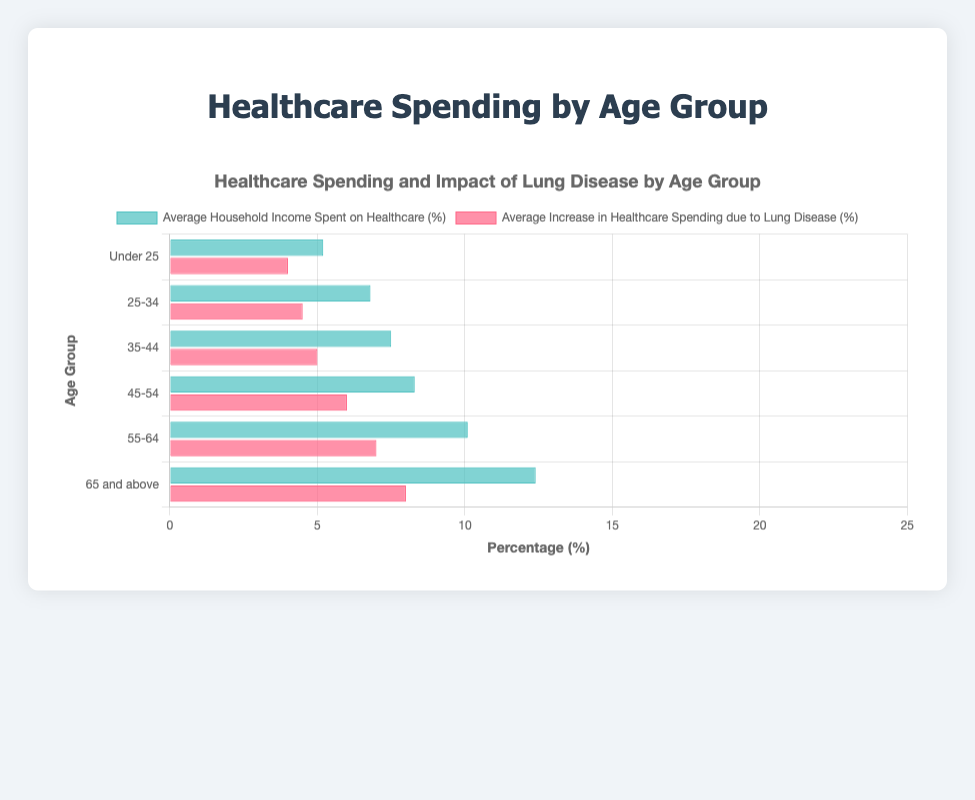Which age group spends the highest percentage of household income on healthcare? Look at the data bars for "Average Household Income Spent on Healthcare (%)". The highest value is 12.4% for the age group "65 and above".
Answer: 65 and above How much more do individuals aged 65 and above spend on healthcare compared to those under 25? Subtract the percentage for "Under 25" from the percentage for "65 and above". That is 12.4% - 5.2% = 7.2%.
Answer: 7.2% What is the increase in healthcare spending due to lung disease for the 55-64 age group? Look at the data bar labeled "Average Increase in Healthcare Spending due to Lung Disease (%)" for the age group "55-64". The value is 7.0%.
Answer: 7.0% Which age group sees the largest increase in healthcare spending due to lung disease? Compare the values in "Average Increase in Healthcare Spending due to Lung Disease (%)" across all age groups. The highest value is 8.0% for "65 and above".
Answer: 65 and above For the age group 45-54, what is the combined total percentage of household income spent on healthcare including the impact of lung disease? Add the values of "Average Household Income Spent on Healthcare (%)" and "Average Increase in Healthcare Spending due to Lung Disease (%)" for the age group 45-54. That is 8.3% + 6.0% = 14.3%.
Answer: 14.3% By how much does healthcare spending due to lung disease increase from the age group 35-44 to 45-54? Subtract the percentage for 35-44 (5.0%) from the percentage for 45-54 (6.0%). Thus, 6.0% - 5.0% = 1.0%.
Answer: 1.0% Is the household income spent on healthcare always increasing with age? Look at the values for "Average Household Income Spent on Healthcare (%)" across all age groups sequentially. The values consistently increase from 5.2% for "Under 25" to 12.4% for "65 and above".
Answer: Yes If one combines the percentage spent on healthcare and the impact of lung disease for the age group 25-34, how does it compare to the total for the 65 and above age group without considering lung disease? For 25-34, sum the percentages: 6.8% + 4.5% = 11.3%. Compare this to 12.4% for 65 and above. Thus, 11.3% for 25-34 is less than 12.4% for 65 and above.
Answer: Less What is the visual representation's color for the increase in healthcare spending due to lung disease? Observe the bar color corresponding to the label “Average Increase in Healthcare Spending due to Lung Disease (%)”. The visual representation uses the color red.
Answer: Red Does the increase in healthcare spending due to lung disease grow faster with age than the average household income spent on healthcare? Compare the increments in both categories across age groups. The increase in lung disease from "Under 25" to "65 and above" is 8.0% - 4.0% = 4.0%. For average household income spent, it’s 12.4% - 5.2% = 7.2%. The increase in lung disease grows slower than the average household income spent on healthcare.
Answer: No 